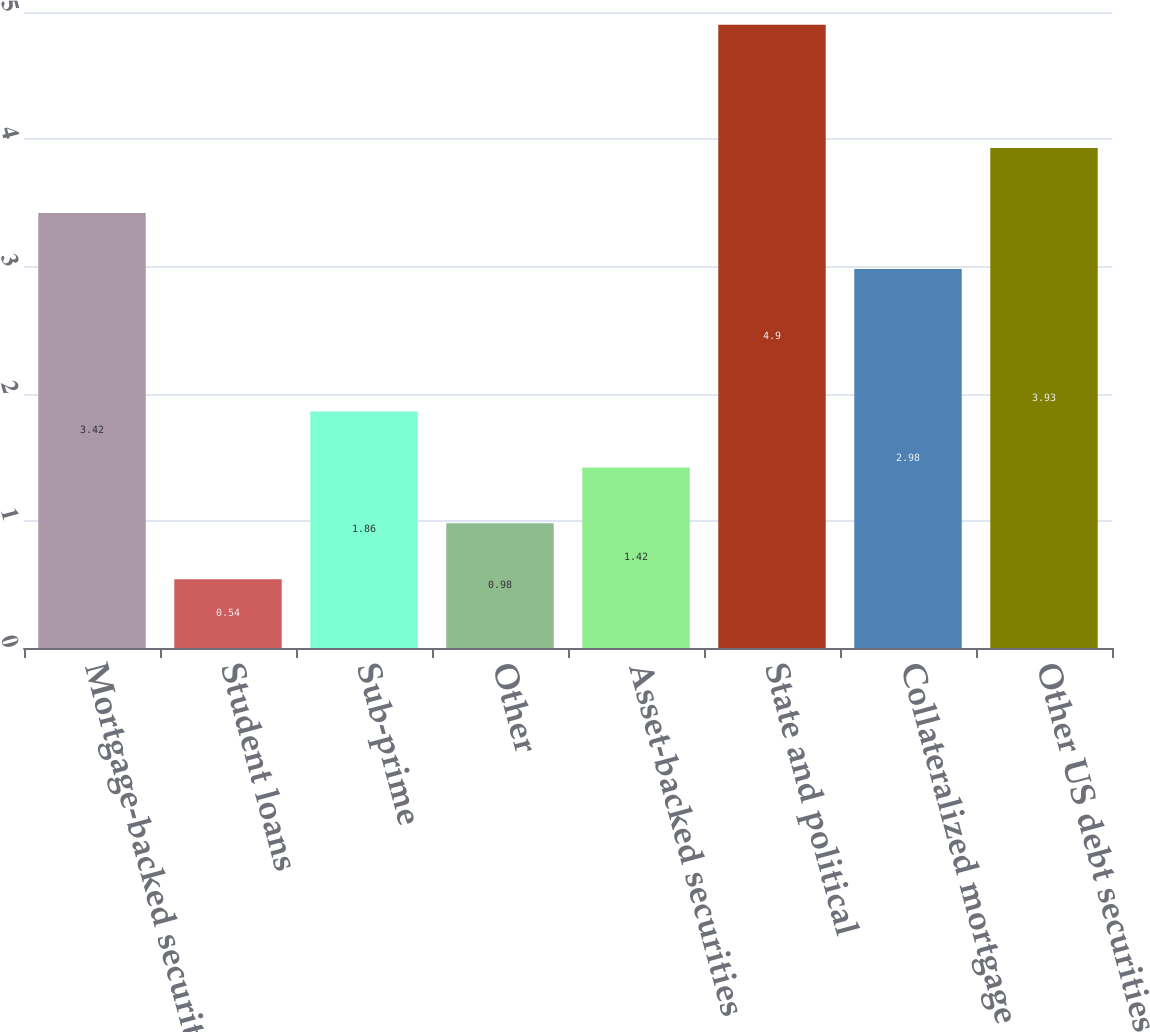Convert chart to OTSL. <chart><loc_0><loc_0><loc_500><loc_500><bar_chart><fcel>Mortgage-backed securities<fcel>Student loans<fcel>Sub-prime<fcel>Other<fcel>Asset-backed securities<fcel>State and political<fcel>Collateralized mortgage<fcel>Other US debt securities<nl><fcel>3.42<fcel>0.54<fcel>1.86<fcel>0.98<fcel>1.42<fcel>4.9<fcel>2.98<fcel>3.93<nl></chart> 